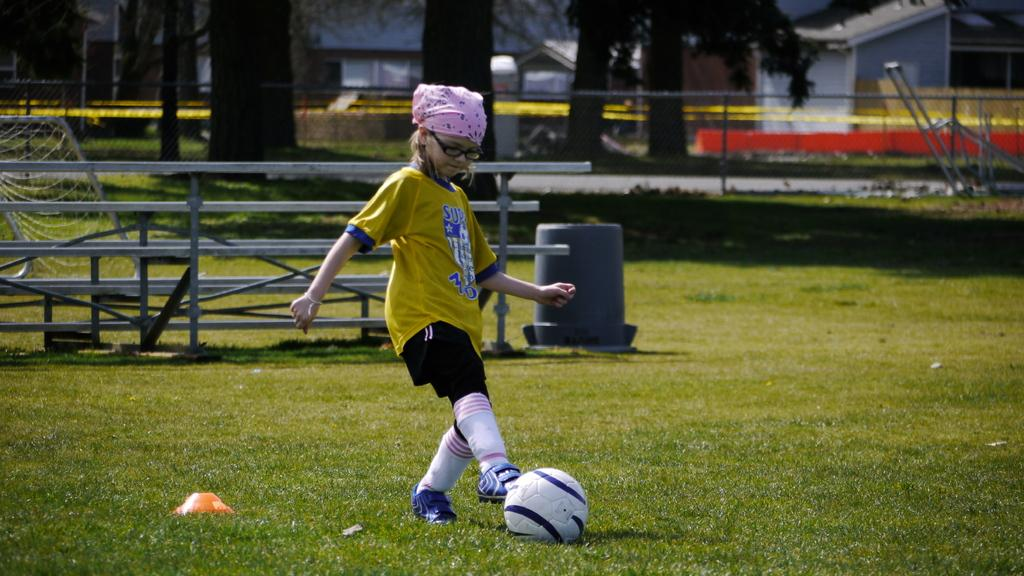Who is the main subject in the image? There is a girl in the image. What is the girl doing in the image? The girl is playing with a ball. Can you describe the girl's clothing in the image? The girl is wearing trousers, socks, and shoes. She also has short hair. What can be seen in the background of the image? There are trees, a house, grass, and plants in the background of the image. What type of power does the minister have in the image? There is no minister present in the image, so it is not possible to determine the type of power they might have. 